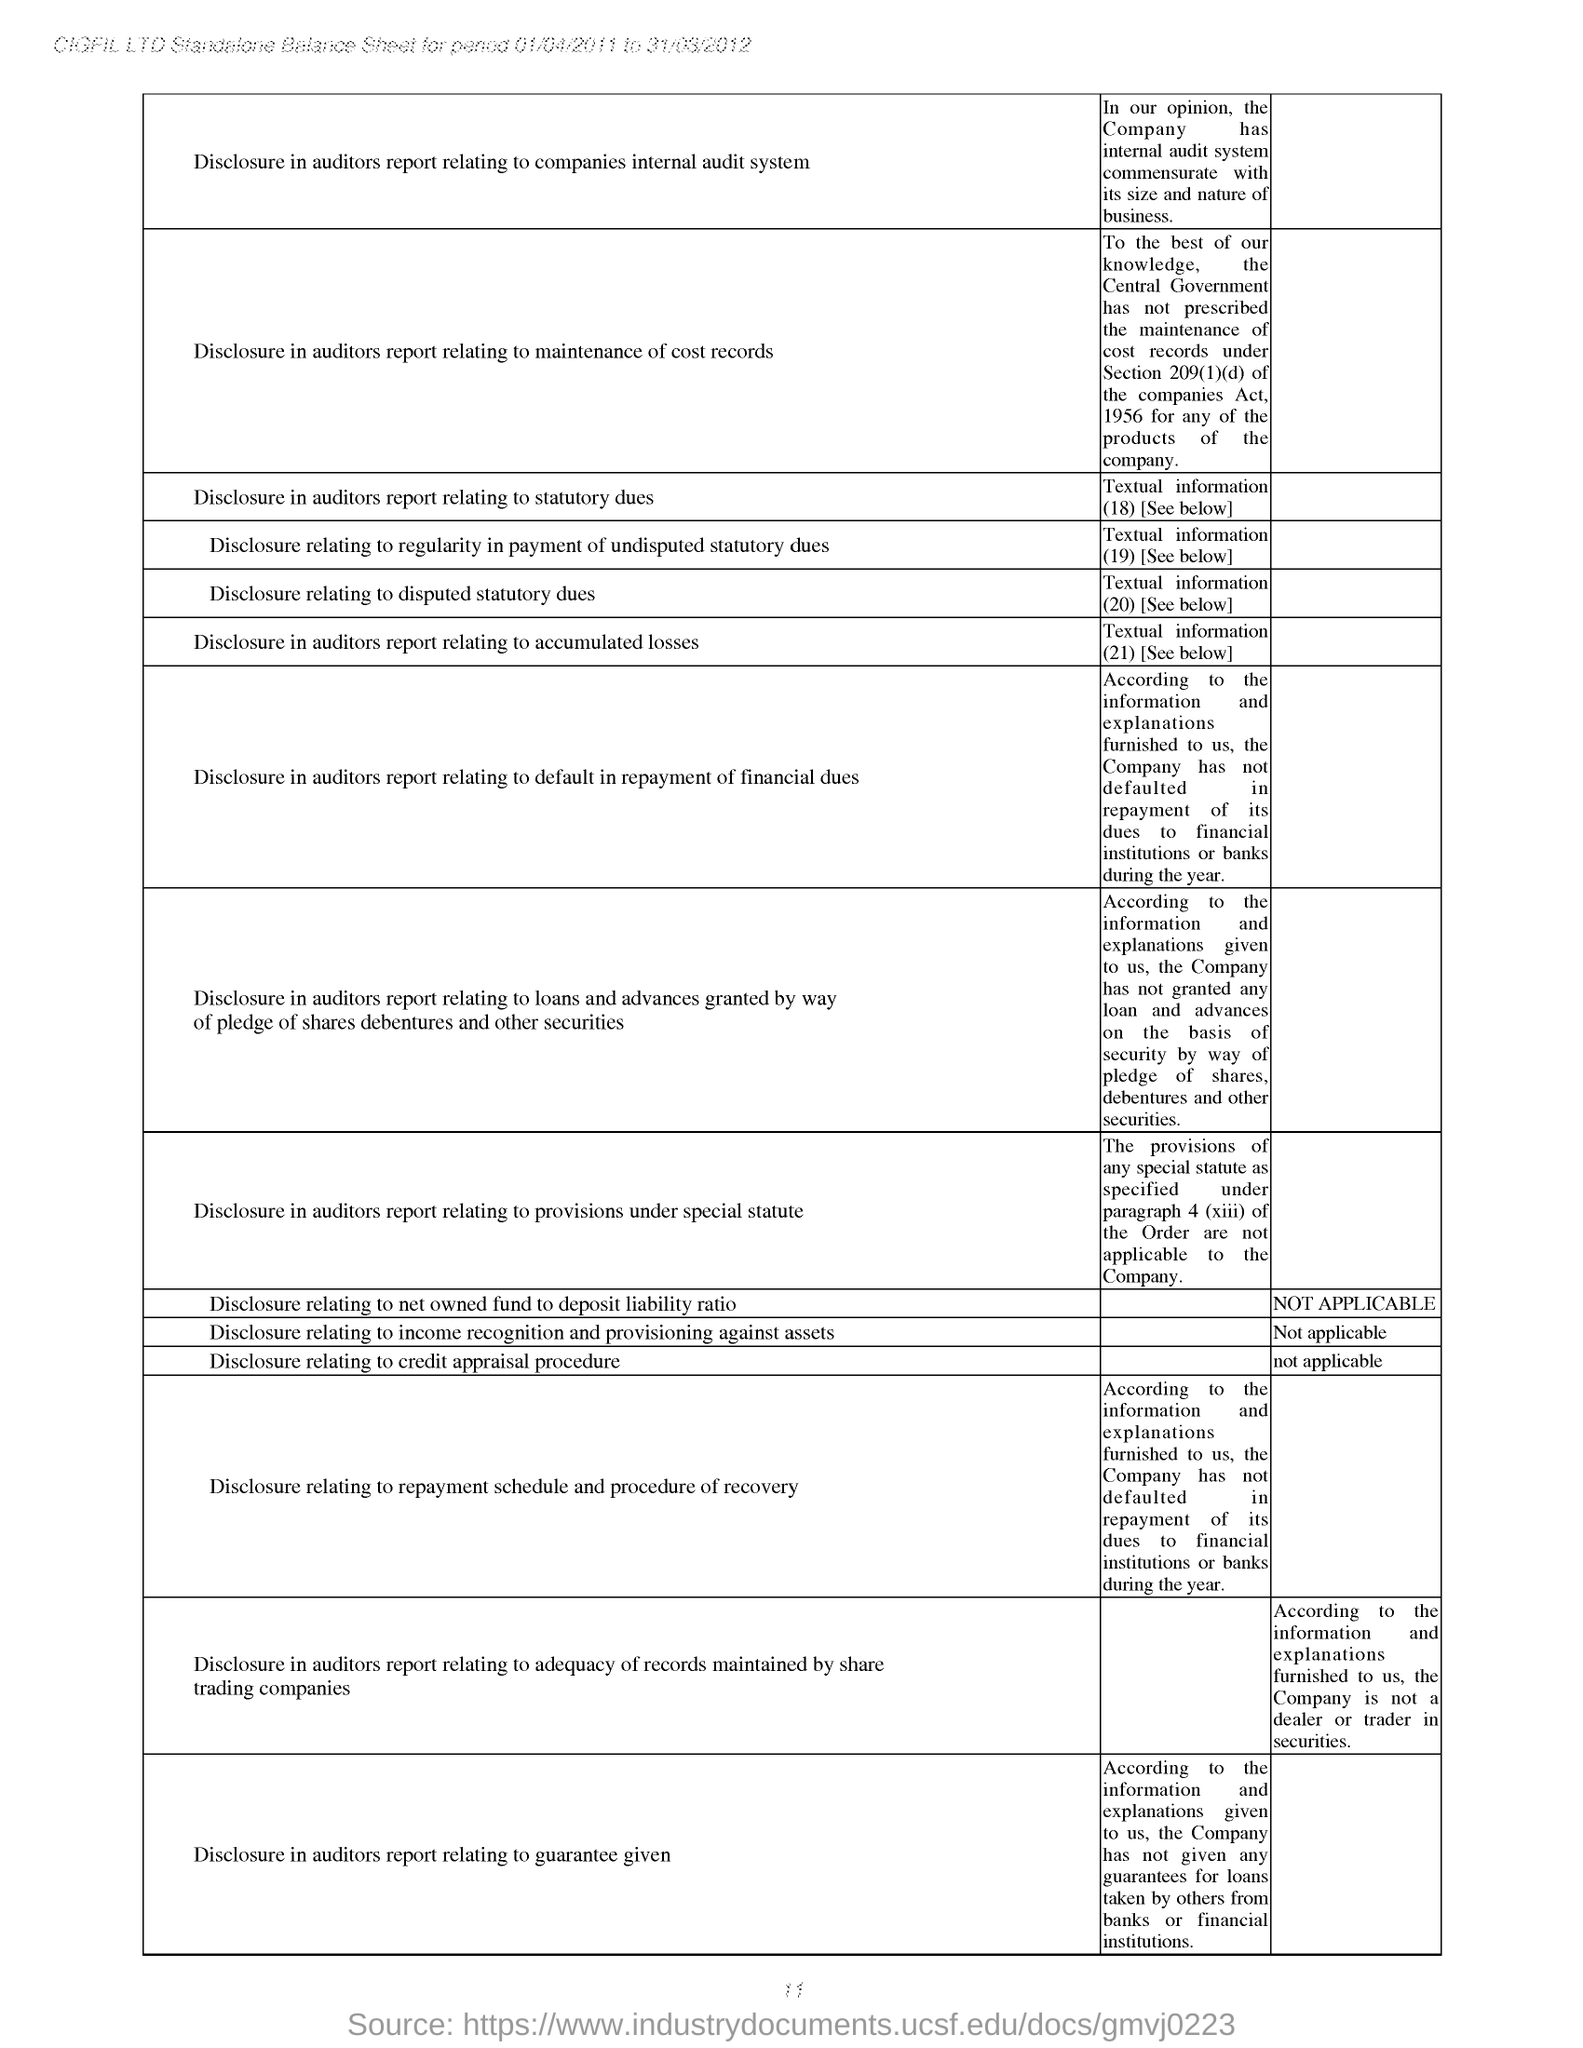Mention a couple of crucial points in this snapshot. The last disclosure mentioned in the balance sheet is the auditor's report relating to a guarantee given. The balance sheet provided for the period of 01/04/2011 to 31/03/2012 belongs to CIGFIL LTD. The first disclosure mentioned in the balance sheet is regarding the disclosure in the auditor's report related to the company's internal audit system. The company named at the top of the balance sheet is CIGFIL LTD.. 